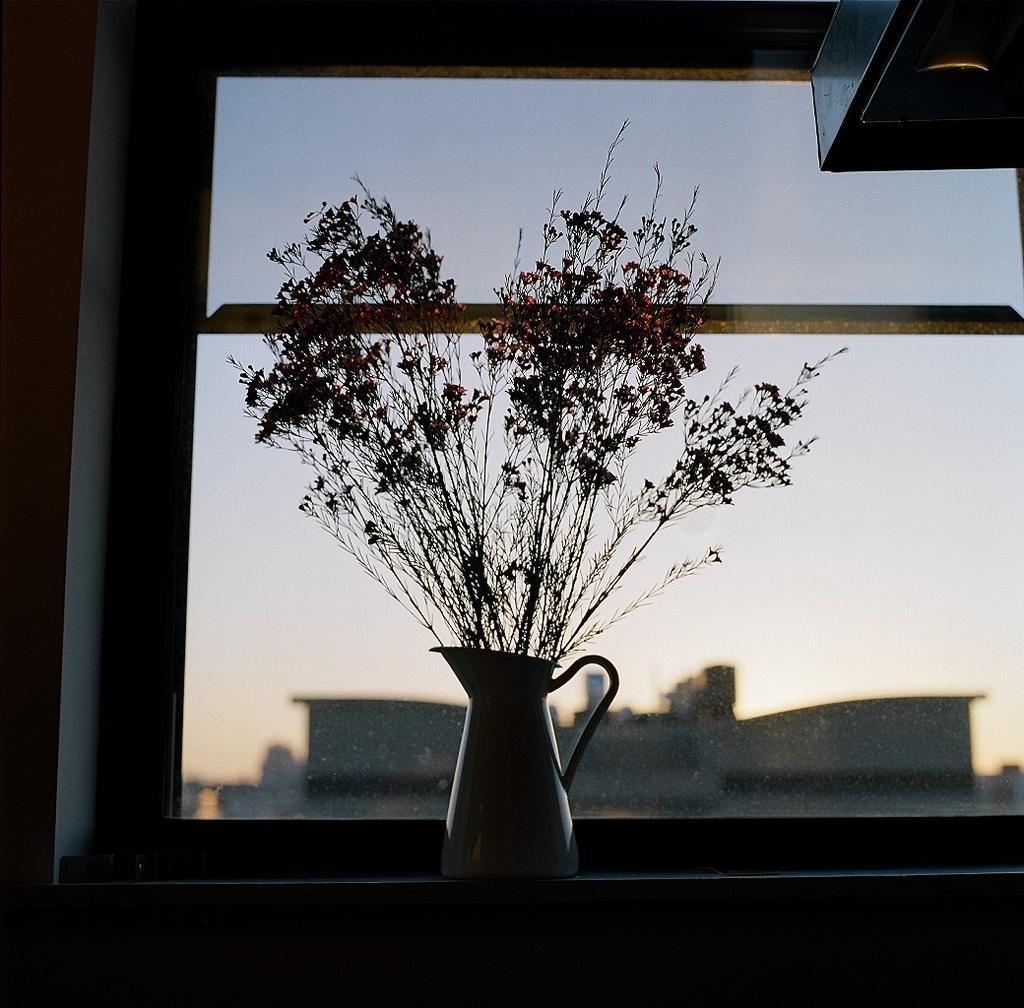What is the main object in the image? There is a water jar in the image. Where is the water jar located in relation to other elements in the image? The water jar is near a window. What can be seen through the window? Buildings and the sky are visible through the window. What type of gold ornament is hanging from the water jar in the image? There is no gold ornament hanging from the water jar in the image. What type of learning activity is taking place in the yard, as seen from the window? There is no learning activity or yard visible in the image; it only shows a water jar near a window with a view of buildings and the sky. 